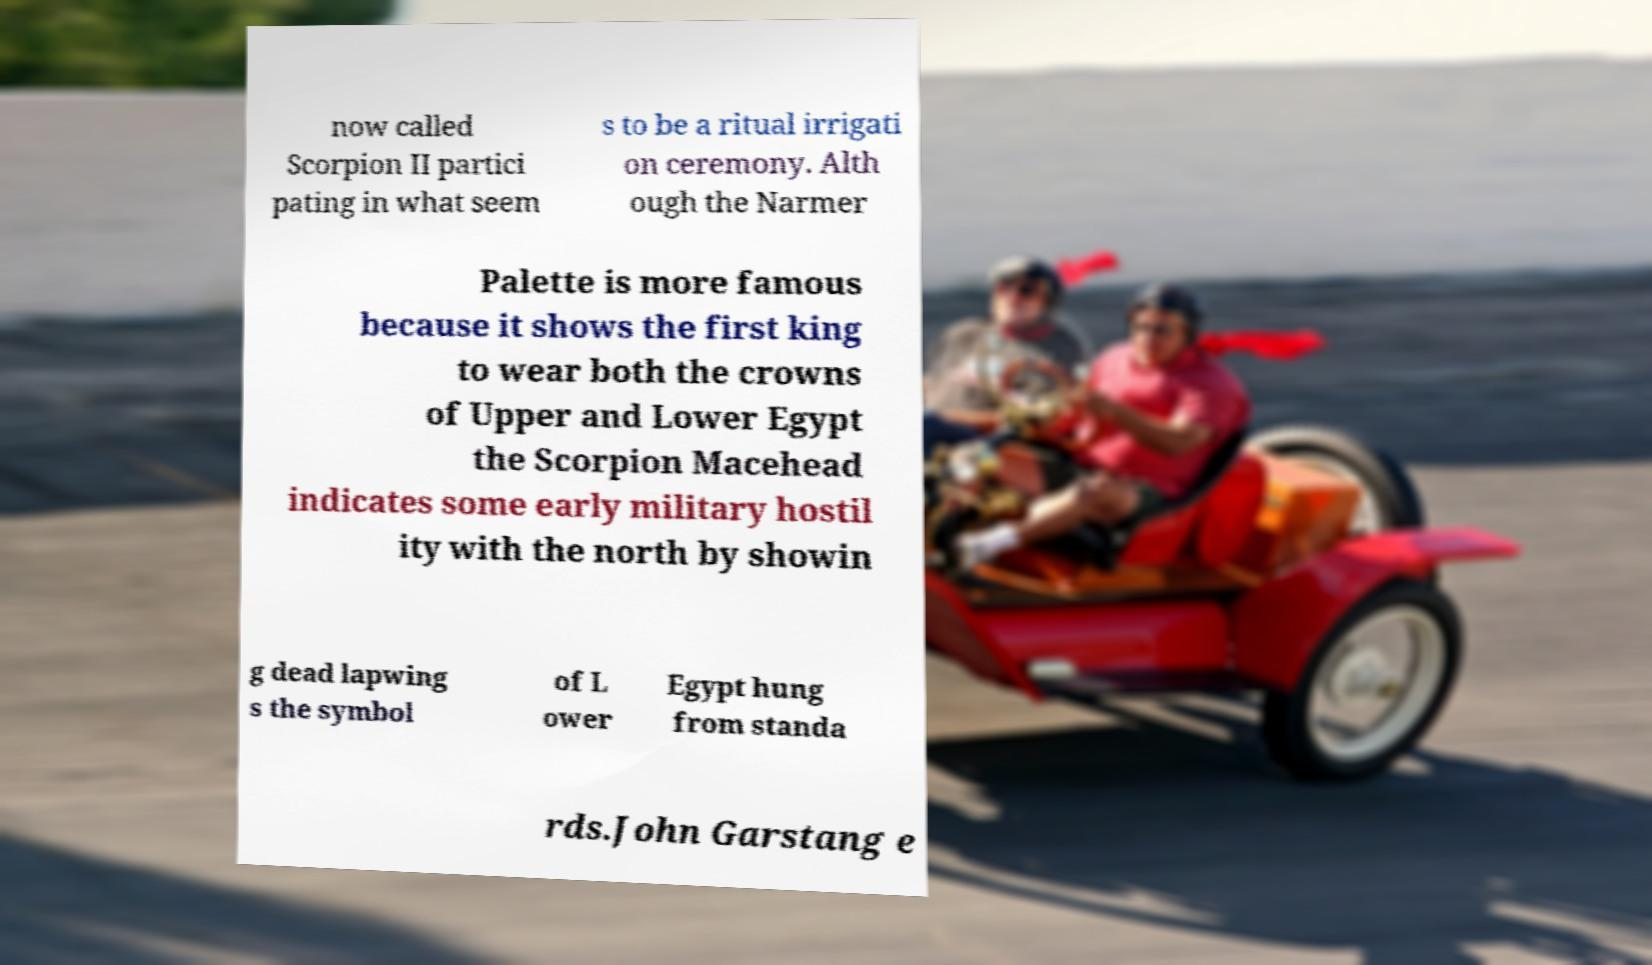Please read and relay the text visible in this image. What does it say? now called Scorpion II partici pating in what seem s to be a ritual irrigati on ceremony. Alth ough the Narmer Palette is more famous because it shows the first king to wear both the crowns of Upper and Lower Egypt the Scorpion Macehead indicates some early military hostil ity with the north by showin g dead lapwing s the symbol of L ower Egypt hung from standa rds.John Garstang e 